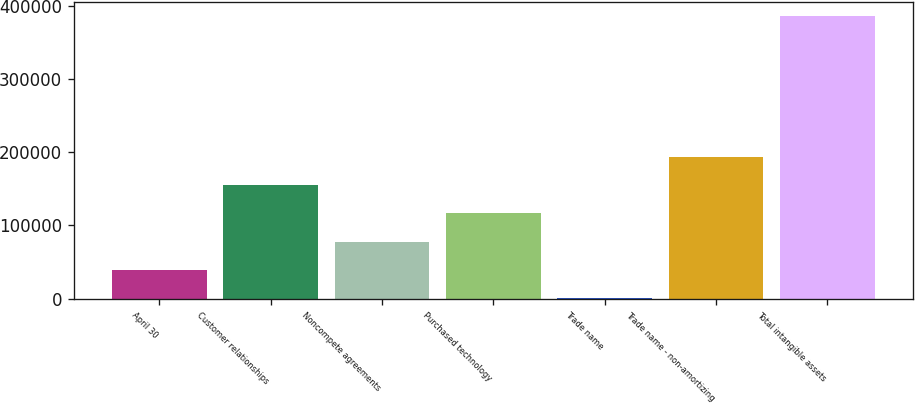Convert chart to OTSL. <chart><loc_0><loc_0><loc_500><loc_500><bar_chart><fcel>April 30<fcel>Customer relationships<fcel>Noncompete agreements<fcel>Purchased technology<fcel>Trade name<fcel>Trade name - non-amortizing<fcel>Total intangible assets<nl><fcel>39327<fcel>154884<fcel>77846<fcel>116365<fcel>808<fcel>193403<fcel>385998<nl></chart> 